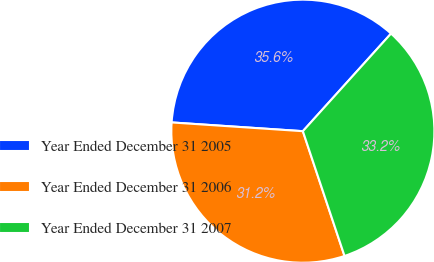Convert chart. <chart><loc_0><loc_0><loc_500><loc_500><pie_chart><fcel>Year Ended December 31 2005<fcel>Year Ended December 31 2006<fcel>Year Ended December 31 2007<nl><fcel>35.63%<fcel>31.19%<fcel>33.18%<nl></chart> 